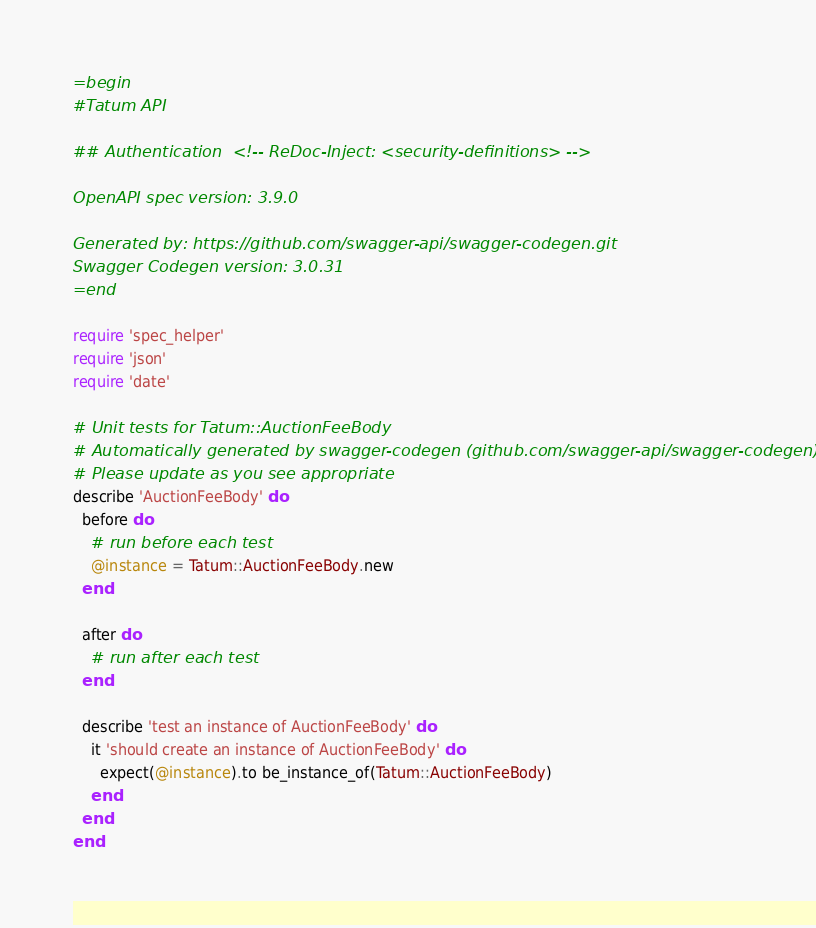Convert code to text. <code><loc_0><loc_0><loc_500><loc_500><_Ruby_>=begin
#Tatum API

## Authentication  <!-- ReDoc-Inject: <security-definitions> -->

OpenAPI spec version: 3.9.0

Generated by: https://github.com/swagger-api/swagger-codegen.git
Swagger Codegen version: 3.0.31
=end

require 'spec_helper'
require 'json'
require 'date'

# Unit tests for Tatum::AuctionFeeBody
# Automatically generated by swagger-codegen (github.com/swagger-api/swagger-codegen)
# Please update as you see appropriate
describe 'AuctionFeeBody' do
  before do
    # run before each test
    @instance = Tatum::AuctionFeeBody.new
  end

  after do
    # run after each test
  end

  describe 'test an instance of AuctionFeeBody' do
    it 'should create an instance of AuctionFeeBody' do
      expect(@instance).to be_instance_of(Tatum::AuctionFeeBody)
    end
  end
end
</code> 